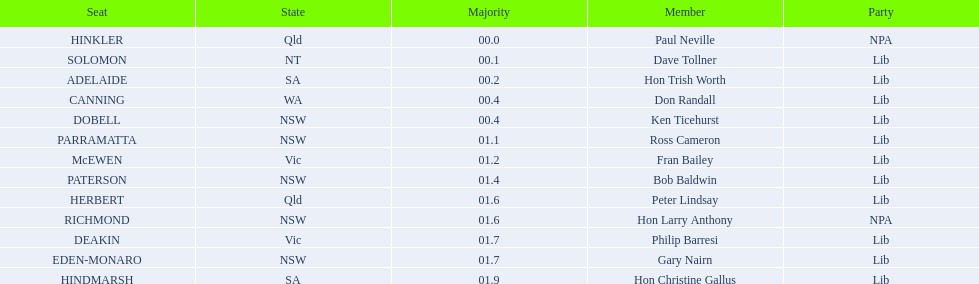Who is the member succeeding hon trish worth? Don Randall. 